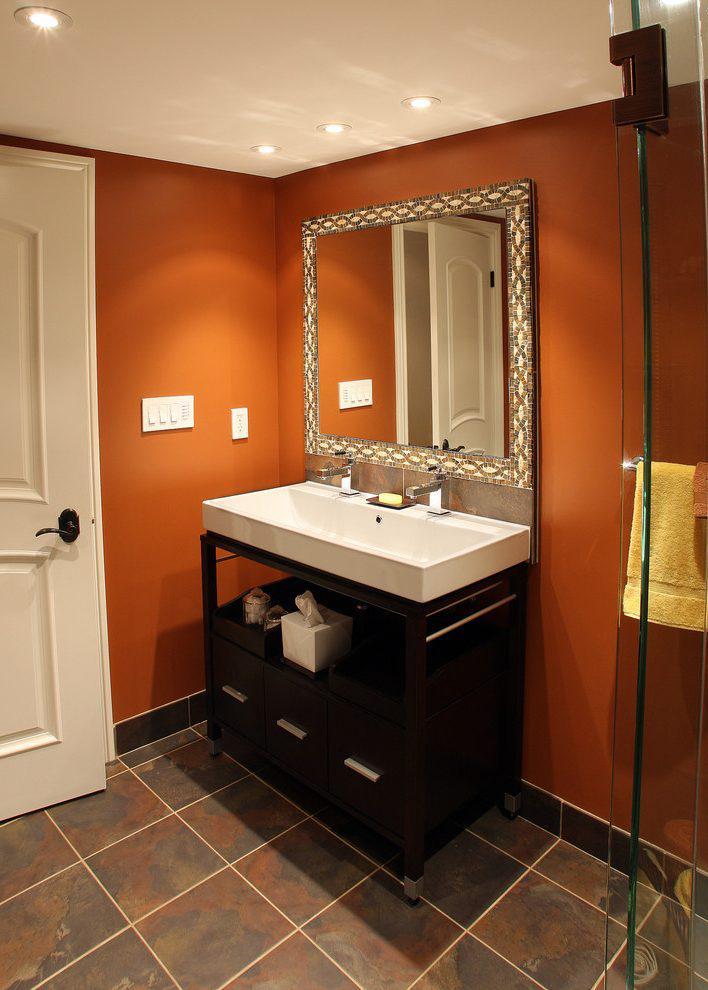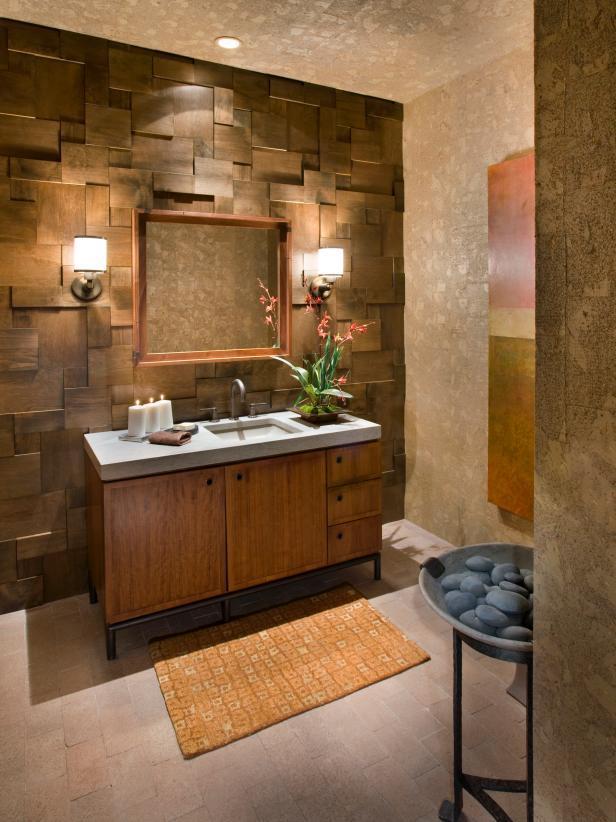The first image is the image on the left, the second image is the image on the right. Considering the images on both sides, is "There are two sinks on top of cabinets." valid? Answer yes or no. Yes. The first image is the image on the left, the second image is the image on the right. Considering the images on both sides, is "Mirrors hang over a sink in each of the images." valid? Answer yes or no. Yes. 